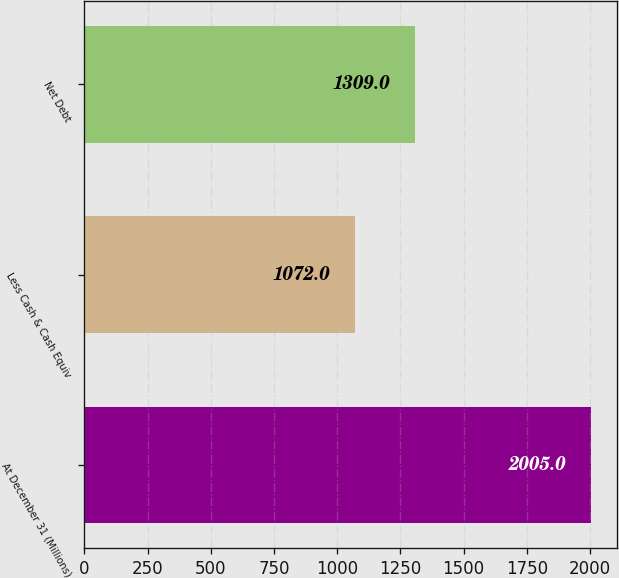Convert chart. <chart><loc_0><loc_0><loc_500><loc_500><bar_chart><fcel>At December 31 (Millions)<fcel>Less Cash & Cash Equiv<fcel>Net Debt<nl><fcel>2005<fcel>1072<fcel>1309<nl></chart> 